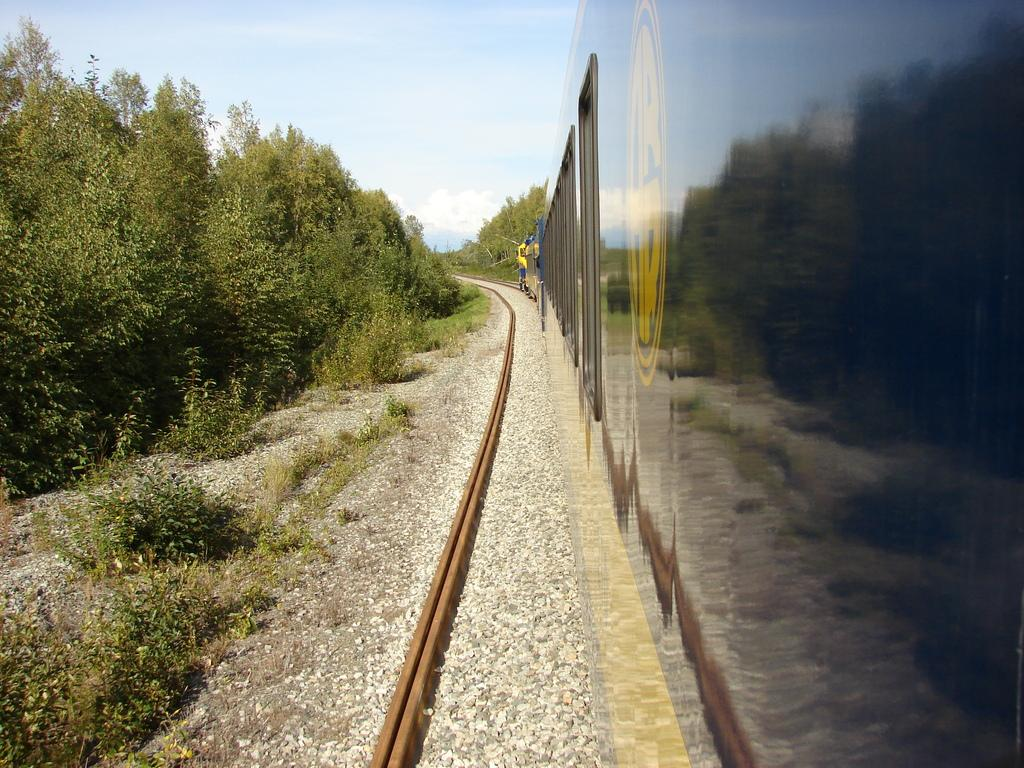Where was the image taken? The image was clicked outside. What can be seen on the right side of the image? There is a train on the right side of the image. What type of vegetation is on the left side of the image? There are trees on the left side of the image. What is visible at the top of the image? The sky is visible at the top of the image. What is the rate of the waves in the image? There are no waves present in the image, so it is not possible to determine a rate. 